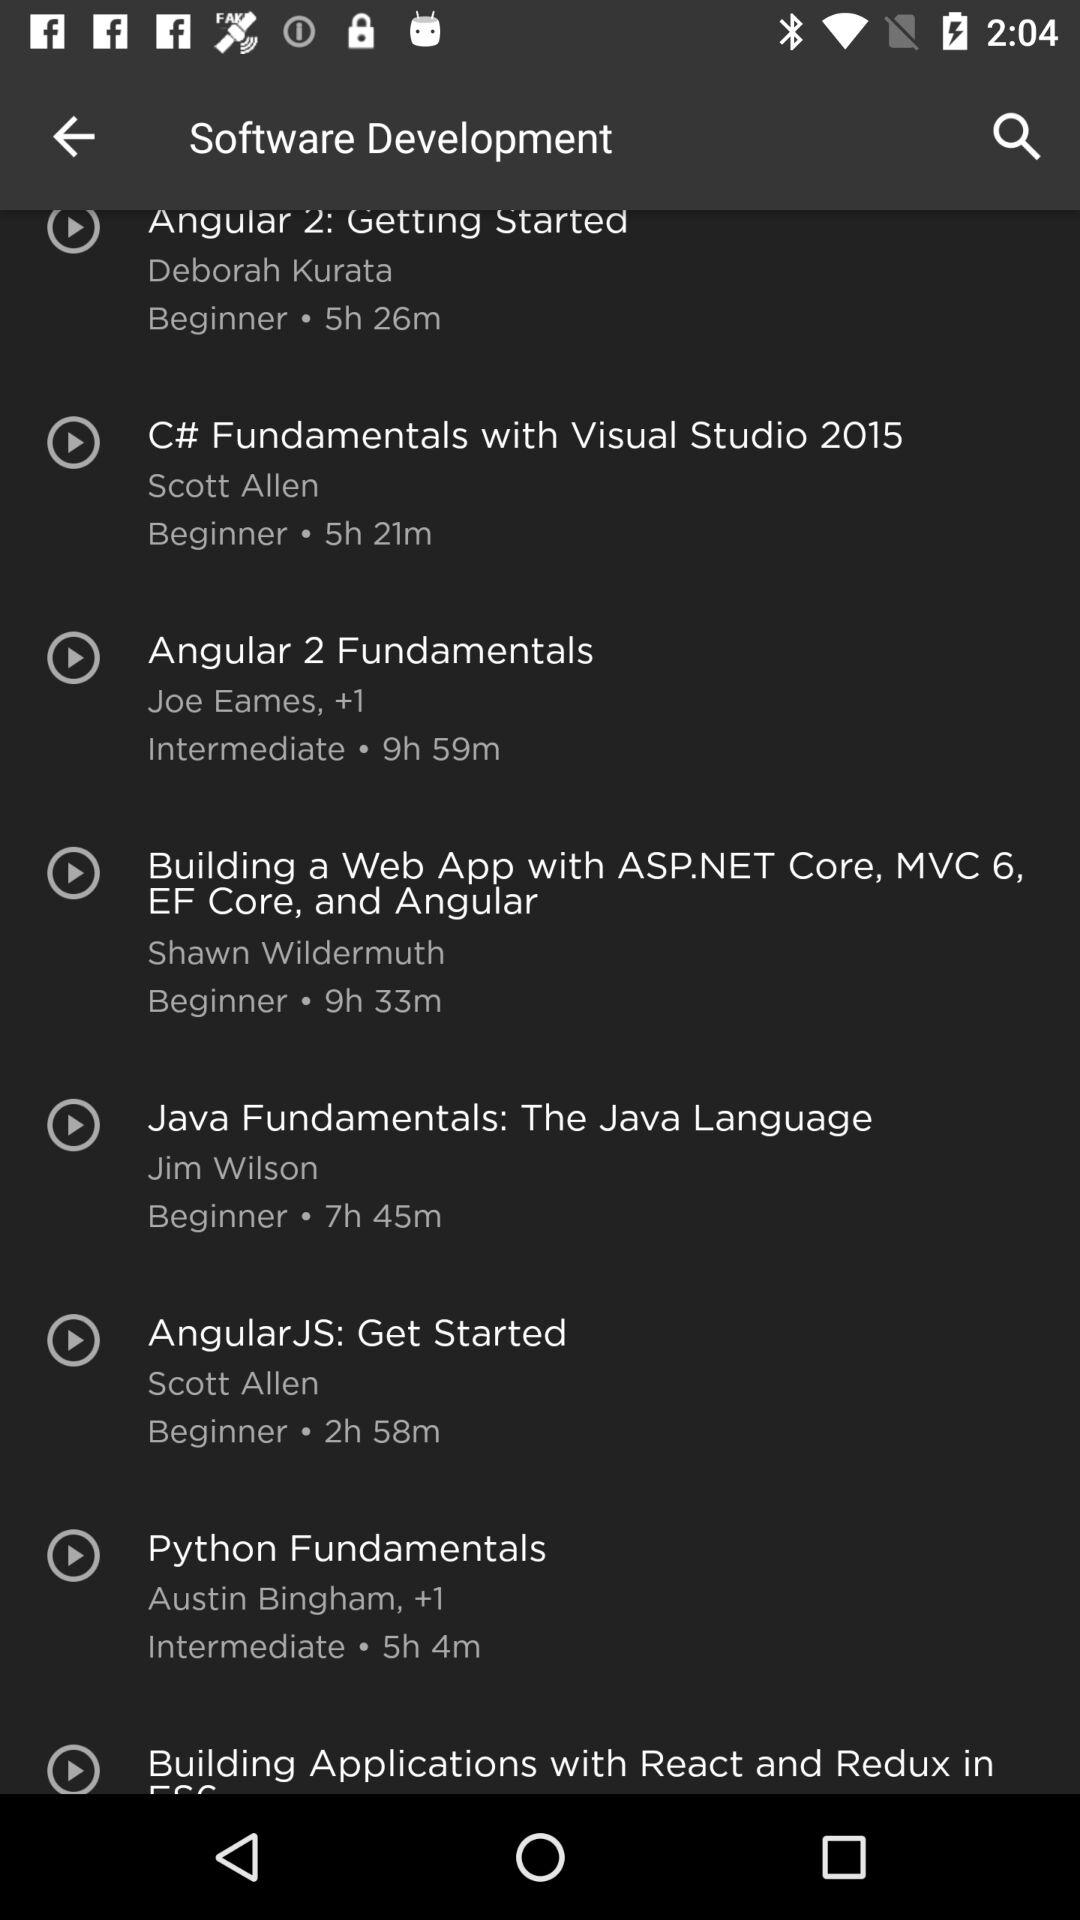What is the duration of the "Python Fundamentals" course? The duration is 5 hours 4 minutes. 